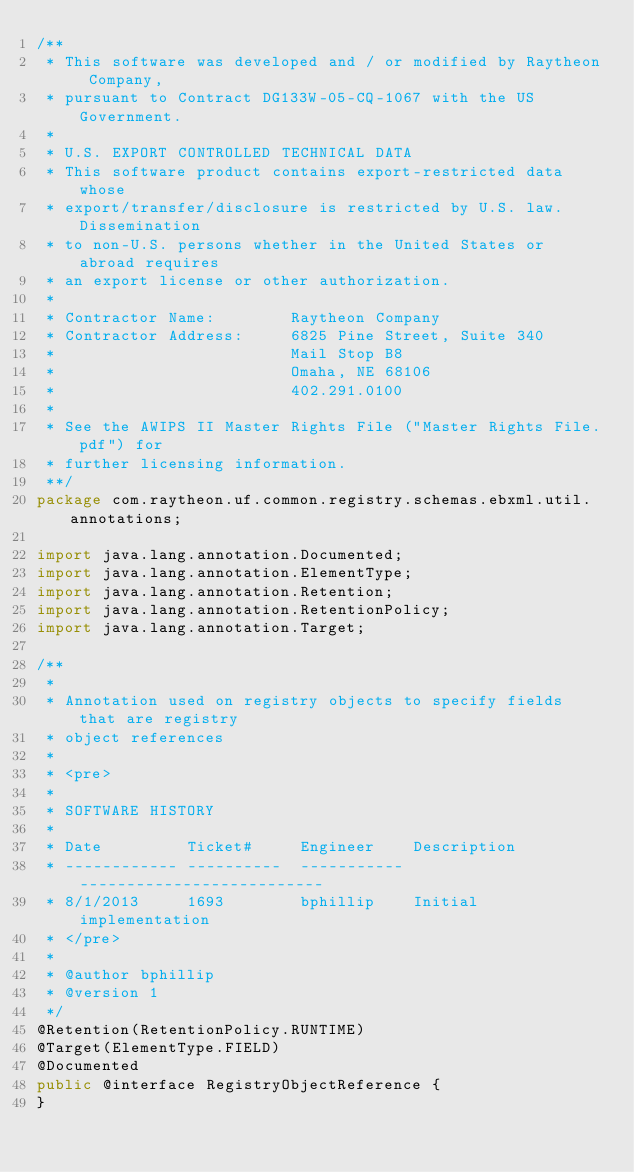<code> <loc_0><loc_0><loc_500><loc_500><_Java_>/**
 * This software was developed and / or modified by Raytheon Company,
 * pursuant to Contract DG133W-05-CQ-1067 with the US Government.
 * 
 * U.S. EXPORT CONTROLLED TECHNICAL DATA
 * This software product contains export-restricted data whose
 * export/transfer/disclosure is restricted by U.S. law. Dissemination
 * to non-U.S. persons whether in the United States or abroad requires
 * an export license or other authorization.
 * 
 * Contractor Name:        Raytheon Company
 * Contractor Address:     6825 Pine Street, Suite 340
 *                         Mail Stop B8
 *                         Omaha, NE 68106
 *                         402.291.0100
 * 
 * See the AWIPS II Master Rights File ("Master Rights File.pdf") for
 * further licensing information.
 **/
package com.raytheon.uf.common.registry.schemas.ebxml.util.annotations;

import java.lang.annotation.Documented;
import java.lang.annotation.ElementType;
import java.lang.annotation.Retention;
import java.lang.annotation.RetentionPolicy;
import java.lang.annotation.Target;

/**
 * 
 * Annotation used on registry objects to specify fields that are registry
 * object references
 * 
 * <pre>
 * 
 * SOFTWARE HISTORY
 * 
 * Date         Ticket#     Engineer    Description
 * ------------ ----------  ----------- --------------------------
 * 8/1/2013     1693        bphillip    Initial implementation
 * </pre>
 * 
 * @author bphillip
 * @version 1
 */
@Retention(RetentionPolicy.RUNTIME)
@Target(ElementType.FIELD)
@Documented
public @interface RegistryObjectReference {
}
</code> 